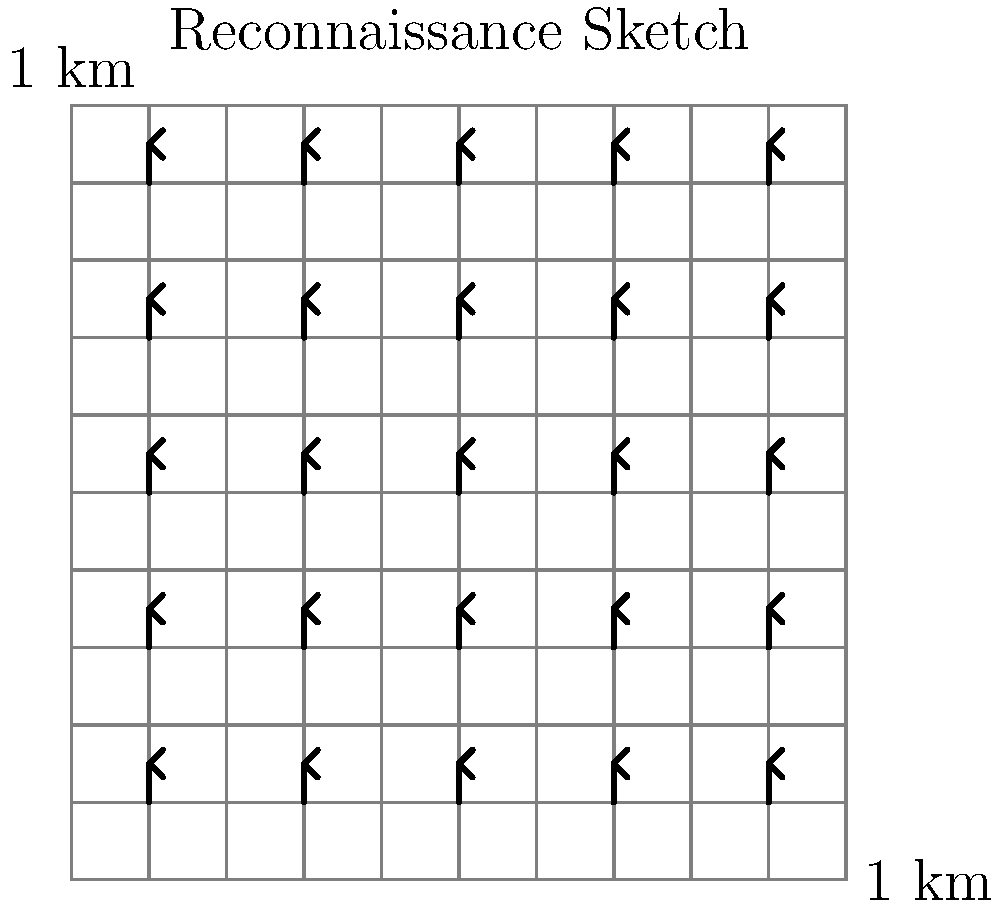Based on the reconnaissance sketch of an enemy formation, estimate the total troop strength if each infantry symbol represents a platoon of 40 soldiers. The grid squares represent 1 km x 1 km areas. To estimate the total troop strength, we need to follow these steps:

1. Count the number of infantry symbols in the sketch:
   There are 5 rows and 5 columns of infantry symbols.
   Total symbols = 5 × 5 = 25 infantry symbols

2. Determine the strength of each symbol:
   Each infantry symbol represents a platoon of 40 soldiers.

3. Calculate the total troop strength:
   Total troops = Number of symbols × Troops per symbol
   Total troops = 25 × 40 = 1,000 soldiers

4. Analyze the tactical implications:
   The formation appears to be a square, covering an area of approximately 4 km × 4 km.
   This suggests a strong, defensible position with good coverage of the terrain.

5. Consider potential variations:
   In real-world scenarios, not all platoons may be at full strength, and there might be support units not represented in the sketch. However, for this estimation, we assume full strength and uniform composition.

Therefore, based on the reconnaissance sketch, the estimated total troop strength is 1,000 soldiers.
Answer: 1,000 soldiers 